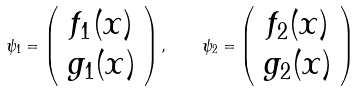<formula> <loc_0><loc_0><loc_500><loc_500>\psi _ { 1 } = \left ( \begin{array} { c } f _ { 1 } ( x ) \\ g _ { 1 } ( x ) \end{array} \right ) , \quad \psi _ { 2 } = \left ( \begin{array} { c } f _ { 2 } ( x ) \\ g _ { 2 } ( x ) \end{array} \right )</formula> 